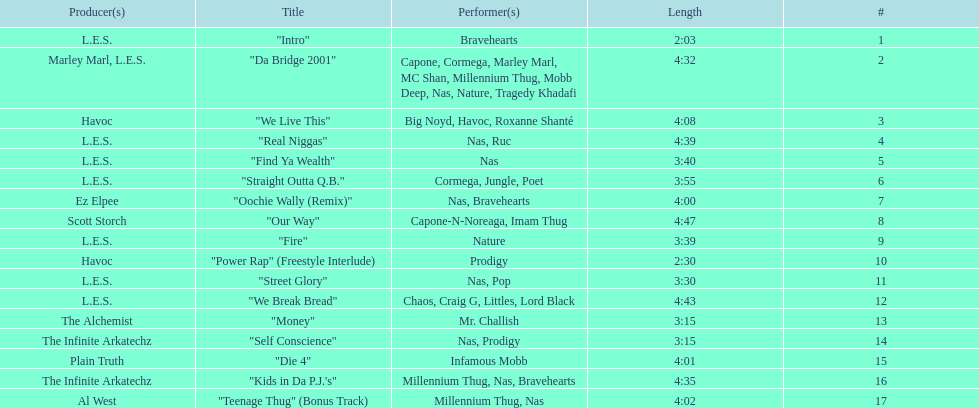How long is the longest track listed? 4:47. Would you be able to parse every entry in this table? {'header': ['Producer(s)', 'Title', 'Performer(s)', 'Length', '#'], 'rows': [['L.E.S.', '"Intro"', 'Bravehearts', '2:03', '1'], ['Marley Marl, L.E.S.', '"Da Bridge 2001"', 'Capone, Cormega, Marley Marl, MC Shan, Millennium Thug, Mobb Deep, Nas, Nature, Tragedy Khadafi', '4:32', '2'], ['Havoc', '"We Live This"', 'Big Noyd, Havoc, Roxanne Shanté', '4:08', '3'], ['L.E.S.', '"Real Niggas"', 'Nas, Ruc', '4:39', '4'], ['L.E.S.', '"Find Ya Wealth"', 'Nas', '3:40', '5'], ['L.E.S.', '"Straight Outta Q.B."', 'Cormega, Jungle, Poet', '3:55', '6'], ['Ez Elpee', '"Oochie Wally (Remix)"', 'Nas, Bravehearts', '4:00', '7'], ['Scott Storch', '"Our Way"', 'Capone-N-Noreaga, Imam Thug', '4:47', '8'], ['L.E.S.', '"Fire"', 'Nature', '3:39', '9'], ['Havoc', '"Power Rap" (Freestyle Interlude)', 'Prodigy', '2:30', '10'], ['L.E.S.', '"Street Glory"', 'Nas, Pop', '3:30', '11'], ['L.E.S.', '"We Break Bread"', 'Chaos, Craig G, Littles, Lord Black', '4:43', '12'], ['The Alchemist', '"Money"', 'Mr. Challish', '3:15', '13'], ['The Infinite Arkatechz', '"Self Conscience"', 'Nas, Prodigy', '3:15', '14'], ['Plain Truth', '"Die 4"', 'Infamous Mobb', '4:01', '15'], ['The Infinite Arkatechz', '"Kids in Da P.J.\'s"', 'Millennium Thug, Nas, Bravehearts', '4:35', '16'], ['Al West', '"Teenage Thug" (Bonus Track)', 'Millennium Thug, Nas', '4:02', '17']]} 